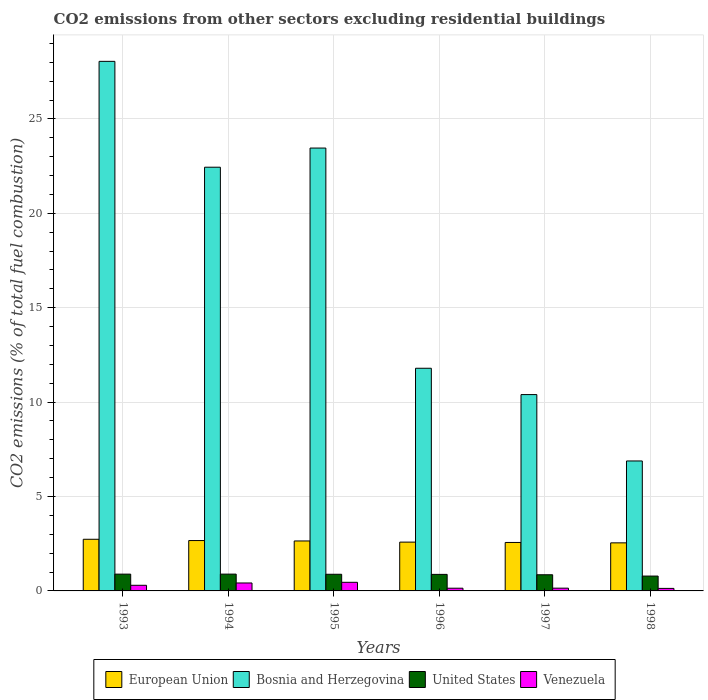How many bars are there on the 2nd tick from the right?
Make the answer very short. 4. What is the label of the 1st group of bars from the left?
Your answer should be compact. 1993. In how many cases, is the number of bars for a given year not equal to the number of legend labels?
Your answer should be very brief. 0. What is the total CO2 emitted in European Union in 1995?
Your answer should be compact. 2.65. Across all years, what is the maximum total CO2 emitted in European Union?
Your response must be concise. 2.74. Across all years, what is the minimum total CO2 emitted in Bosnia and Herzegovina?
Your answer should be very brief. 6.88. In which year was the total CO2 emitted in United States maximum?
Provide a short and direct response. 1994. In which year was the total CO2 emitted in Venezuela minimum?
Ensure brevity in your answer.  1998. What is the total total CO2 emitted in European Union in the graph?
Your answer should be compact. 15.75. What is the difference between the total CO2 emitted in Bosnia and Herzegovina in 1993 and that in 1996?
Offer a very short reply. 16.26. What is the difference between the total CO2 emitted in Bosnia and Herzegovina in 1997 and the total CO2 emitted in European Union in 1995?
Give a very brief answer. 7.75. What is the average total CO2 emitted in Venezuela per year?
Give a very brief answer. 0.27. In the year 1993, what is the difference between the total CO2 emitted in European Union and total CO2 emitted in Bosnia and Herzegovina?
Provide a succinct answer. -25.31. In how many years, is the total CO2 emitted in United States greater than 23?
Provide a short and direct response. 0. What is the ratio of the total CO2 emitted in United States in 1994 to that in 1996?
Your answer should be compact. 1.02. Is the total CO2 emitted in Venezuela in 1993 less than that in 1998?
Your answer should be compact. No. Is the difference between the total CO2 emitted in European Union in 1994 and 1996 greater than the difference between the total CO2 emitted in Bosnia and Herzegovina in 1994 and 1996?
Give a very brief answer. No. What is the difference between the highest and the second highest total CO2 emitted in Bosnia and Herzegovina?
Offer a terse response. 4.59. What is the difference between the highest and the lowest total CO2 emitted in United States?
Provide a short and direct response. 0.1. In how many years, is the total CO2 emitted in Bosnia and Herzegovina greater than the average total CO2 emitted in Bosnia and Herzegovina taken over all years?
Offer a very short reply. 3. Is the sum of the total CO2 emitted in Venezuela in 1993 and 1994 greater than the maximum total CO2 emitted in Bosnia and Herzegovina across all years?
Your response must be concise. No. What does the 3rd bar from the right in 1994 represents?
Provide a short and direct response. Bosnia and Herzegovina. How many bars are there?
Your answer should be very brief. 24. How many years are there in the graph?
Provide a short and direct response. 6. What is the difference between two consecutive major ticks on the Y-axis?
Your answer should be compact. 5. Where does the legend appear in the graph?
Offer a terse response. Bottom center. How are the legend labels stacked?
Your answer should be very brief. Horizontal. What is the title of the graph?
Offer a terse response. CO2 emissions from other sectors excluding residential buildings. Does "Greenland" appear as one of the legend labels in the graph?
Your answer should be very brief. No. What is the label or title of the X-axis?
Give a very brief answer. Years. What is the label or title of the Y-axis?
Give a very brief answer. CO2 emissions (% of total fuel combustion). What is the CO2 emissions (% of total fuel combustion) of European Union in 1993?
Offer a very short reply. 2.74. What is the CO2 emissions (% of total fuel combustion) in Bosnia and Herzegovina in 1993?
Give a very brief answer. 28.05. What is the CO2 emissions (% of total fuel combustion) of United States in 1993?
Your response must be concise. 0.89. What is the CO2 emissions (% of total fuel combustion) in Venezuela in 1993?
Keep it short and to the point. 0.3. What is the CO2 emissions (% of total fuel combustion) of European Union in 1994?
Provide a short and direct response. 2.67. What is the CO2 emissions (% of total fuel combustion) in Bosnia and Herzegovina in 1994?
Give a very brief answer. 22.44. What is the CO2 emissions (% of total fuel combustion) of United States in 1994?
Your answer should be compact. 0.89. What is the CO2 emissions (% of total fuel combustion) in Venezuela in 1994?
Offer a very short reply. 0.42. What is the CO2 emissions (% of total fuel combustion) of European Union in 1995?
Your answer should be very brief. 2.65. What is the CO2 emissions (% of total fuel combustion) of Bosnia and Herzegovina in 1995?
Your response must be concise. 23.46. What is the CO2 emissions (% of total fuel combustion) in United States in 1995?
Offer a very short reply. 0.88. What is the CO2 emissions (% of total fuel combustion) of Venezuela in 1995?
Your answer should be very brief. 0.46. What is the CO2 emissions (% of total fuel combustion) of European Union in 1996?
Offer a terse response. 2.58. What is the CO2 emissions (% of total fuel combustion) in Bosnia and Herzegovina in 1996?
Offer a terse response. 11.79. What is the CO2 emissions (% of total fuel combustion) of United States in 1996?
Your answer should be compact. 0.88. What is the CO2 emissions (% of total fuel combustion) in Venezuela in 1996?
Keep it short and to the point. 0.14. What is the CO2 emissions (% of total fuel combustion) in European Union in 1997?
Give a very brief answer. 2.57. What is the CO2 emissions (% of total fuel combustion) of Bosnia and Herzegovina in 1997?
Keep it short and to the point. 10.4. What is the CO2 emissions (% of total fuel combustion) in United States in 1997?
Give a very brief answer. 0.86. What is the CO2 emissions (% of total fuel combustion) of Venezuela in 1997?
Make the answer very short. 0.15. What is the CO2 emissions (% of total fuel combustion) in European Union in 1998?
Your response must be concise. 2.55. What is the CO2 emissions (% of total fuel combustion) in Bosnia and Herzegovina in 1998?
Provide a succinct answer. 6.88. What is the CO2 emissions (% of total fuel combustion) of United States in 1998?
Ensure brevity in your answer.  0.79. What is the CO2 emissions (% of total fuel combustion) in Venezuela in 1998?
Offer a very short reply. 0.13. Across all years, what is the maximum CO2 emissions (% of total fuel combustion) of European Union?
Your response must be concise. 2.74. Across all years, what is the maximum CO2 emissions (% of total fuel combustion) in Bosnia and Herzegovina?
Give a very brief answer. 28.05. Across all years, what is the maximum CO2 emissions (% of total fuel combustion) of United States?
Make the answer very short. 0.89. Across all years, what is the maximum CO2 emissions (% of total fuel combustion) of Venezuela?
Make the answer very short. 0.46. Across all years, what is the minimum CO2 emissions (% of total fuel combustion) of European Union?
Provide a succinct answer. 2.55. Across all years, what is the minimum CO2 emissions (% of total fuel combustion) of Bosnia and Herzegovina?
Provide a succinct answer. 6.88. Across all years, what is the minimum CO2 emissions (% of total fuel combustion) in United States?
Provide a succinct answer. 0.79. Across all years, what is the minimum CO2 emissions (% of total fuel combustion) in Venezuela?
Your answer should be compact. 0.13. What is the total CO2 emissions (% of total fuel combustion) in European Union in the graph?
Your answer should be very brief. 15.75. What is the total CO2 emissions (% of total fuel combustion) in Bosnia and Herzegovina in the graph?
Keep it short and to the point. 103.02. What is the total CO2 emissions (% of total fuel combustion) of United States in the graph?
Make the answer very short. 5.18. What is the total CO2 emissions (% of total fuel combustion) in Venezuela in the graph?
Keep it short and to the point. 1.6. What is the difference between the CO2 emissions (% of total fuel combustion) of European Union in 1993 and that in 1994?
Provide a short and direct response. 0.07. What is the difference between the CO2 emissions (% of total fuel combustion) of Bosnia and Herzegovina in 1993 and that in 1994?
Offer a very short reply. 5.61. What is the difference between the CO2 emissions (% of total fuel combustion) in United States in 1993 and that in 1994?
Make the answer very short. -0. What is the difference between the CO2 emissions (% of total fuel combustion) of Venezuela in 1993 and that in 1994?
Provide a succinct answer. -0.12. What is the difference between the CO2 emissions (% of total fuel combustion) of European Union in 1993 and that in 1995?
Ensure brevity in your answer.  0.09. What is the difference between the CO2 emissions (% of total fuel combustion) in Bosnia and Herzegovina in 1993 and that in 1995?
Provide a short and direct response. 4.59. What is the difference between the CO2 emissions (% of total fuel combustion) in United States in 1993 and that in 1995?
Provide a succinct answer. 0.01. What is the difference between the CO2 emissions (% of total fuel combustion) of Venezuela in 1993 and that in 1995?
Offer a very short reply. -0.16. What is the difference between the CO2 emissions (% of total fuel combustion) of European Union in 1993 and that in 1996?
Your answer should be very brief. 0.15. What is the difference between the CO2 emissions (% of total fuel combustion) in Bosnia and Herzegovina in 1993 and that in 1996?
Offer a very short reply. 16.26. What is the difference between the CO2 emissions (% of total fuel combustion) of United States in 1993 and that in 1996?
Provide a short and direct response. 0.01. What is the difference between the CO2 emissions (% of total fuel combustion) of Venezuela in 1993 and that in 1996?
Provide a succinct answer. 0.15. What is the difference between the CO2 emissions (% of total fuel combustion) of European Union in 1993 and that in 1997?
Ensure brevity in your answer.  0.17. What is the difference between the CO2 emissions (% of total fuel combustion) in Bosnia and Herzegovina in 1993 and that in 1997?
Give a very brief answer. 17.65. What is the difference between the CO2 emissions (% of total fuel combustion) in United States in 1993 and that in 1997?
Your answer should be very brief. 0.03. What is the difference between the CO2 emissions (% of total fuel combustion) of Venezuela in 1993 and that in 1997?
Offer a very short reply. 0.15. What is the difference between the CO2 emissions (% of total fuel combustion) of European Union in 1993 and that in 1998?
Your answer should be very brief. 0.19. What is the difference between the CO2 emissions (% of total fuel combustion) in Bosnia and Herzegovina in 1993 and that in 1998?
Keep it short and to the point. 21.17. What is the difference between the CO2 emissions (% of total fuel combustion) of United States in 1993 and that in 1998?
Make the answer very short. 0.1. What is the difference between the CO2 emissions (% of total fuel combustion) in Venezuela in 1993 and that in 1998?
Keep it short and to the point. 0.16. What is the difference between the CO2 emissions (% of total fuel combustion) of European Union in 1994 and that in 1995?
Provide a short and direct response. 0.02. What is the difference between the CO2 emissions (% of total fuel combustion) of Bosnia and Herzegovina in 1994 and that in 1995?
Your answer should be compact. -1.01. What is the difference between the CO2 emissions (% of total fuel combustion) in United States in 1994 and that in 1995?
Ensure brevity in your answer.  0.01. What is the difference between the CO2 emissions (% of total fuel combustion) in Venezuela in 1994 and that in 1995?
Your answer should be very brief. -0.04. What is the difference between the CO2 emissions (% of total fuel combustion) of European Union in 1994 and that in 1996?
Offer a terse response. 0.08. What is the difference between the CO2 emissions (% of total fuel combustion) in Bosnia and Herzegovina in 1994 and that in 1996?
Your answer should be compact. 10.65. What is the difference between the CO2 emissions (% of total fuel combustion) in United States in 1994 and that in 1996?
Make the answer very short. 0.01. What is the difference between the CO2 emissions (% of total fuel combustion) of Venezuela in 1994 and that in 1996?
Provide a succinct answer. 0.28. What is the difference between the CO2 emissions (% of total fuel combustion) in European Union in 1994 and that in 1997?
Make the answer very short. 0.1. What is the difference between the CO2 emissions (% of total fuel combustion) of Bosnia and Herzegovina in 1994 and that in 1997?
Make the answer very short. 12.04. What is the difference between the CO2 emissions (% of total fuel combustion) in United States in 1994 and that in 1997?
Ensure brevity in your answer.  0.03. What is the difference between the CO2 emissions (% of total fuel combustion) of Venezuela in 1994 and that in 1997?
Offer a terse response. 0.27. What is the difference between the CO2 emissions (% of total fuel combustion) of European Union in 1994 and that in 1998?
Provide a succinct answer. 0.12. What is the difference between the CO2 emissions (% of total fuel combustion) of Bosnia and Herzegovina in 1994 and that in 1998?
Provide a short and direct response. 15.56. What is the difference between the CO2 emissions (% of total fuel combustion) of United States in 1994 and that in 1998?
Your answer should be very brief. 0.1. What is the difference between the CO2 emissions (% of total fuel combustion) in Venezuela in 1994 and that in 1998?
Ensure brevity in your answer.  0.29. What is the difference between the CO2 emissions (% of total fuel combustion) of European Union in 1995 and that in 1996?
Provide a short and direct response. 0.06. What is the difference between the CO2 emissions (% of total fuel combustion) in Bosnia and Herzegovina in 1995 and that in 1996?
Ensure brevity in your answer.  11.66. What is the difference between the CO2 emissions (% of total fuel combustion) in United States in 1995 and that in 1996?
Make the answer very short. 0.01. What is the difference between the CO2 emissions (% of total fuel combustion) of Venezuela in 1995 and that in 1996?
Provide a short and direct response. 0.31. What is the difference between the CO2 emissions (% of total fuel combustion) of European Union in 1995 and that in 1997?
Give a very brief answer. 0.08. What is the difference between the CO2 emissions (% of total fuel combustion) in Bosnia and Herzegovina in 1995 and that in 1997?
Your answer should be compact. 13.06. What is the difference between the CO2 emissions (% of total fuel combustion) of United States in 1995 and that in 1997?
Provide a succinct answer. 0.03. What is the difference between the CO2 emissions (% of total fuel combustion) of Venezuela in 1995 and that in 1997?
Your answer should be compact. 0.31. What is the difference between the CO2 emissions (% of total fuel combustion) of European Union in 1995 and that in 1998?
Ensure brevity in your answer.  0.1. What is the difference between the CO2 emissions (% of total fuel combustion) in Bosnia and Herzegovina in 1995 and that in 1998?
Provide a short and direct response. 16.57. What is the difference between the CO2 emissions (% of total fuel combustion) of United States in 1995 and that in 1998?
Make the answer very short. 0.1. What is the difference between the CO2 emissions (% of total fuel combustion) in Venezuela in 1995 and that in 1998?
Your answer should be compact. 0.32. What is the difference between the CO2 emissions (% of total fuel combustion) of European Union in 1996 and that in 1997?
Ensure brevity in your answer.  0.02. What is the difference between the CO2 emissions (% of total fuel combustion) in Bosnia and Herzegovina in 1996 and that in 1997?
Provide a short and direct response. 1.39. What is the difference between the CO2 emissions (% of total fuel combustion) in United States in 1996 and that in 1997?
Your answer should be compact. 0.02. What is the difference between the CO2 emissions (% of total fuel combustion) in Venezuela in 1996 and that in 1997?
Provide a short and direct response. -0. What is the difference between the CO2 emissions (% of total fuel combustion) of European Union in 1996 and that in 1998?
Provide a short and direct response. 0.04. What is the difference between the CO2 emissions (% of total fuel combustion) of Bosnia and Herzegovina in 1996 and that in 1998?
Your answer should be very brief. 4.91. What is the difference between the CO2 emissions (% of total fuel combustion) in United States in 1996 and that in 1998?
Provide a short and direct response. 0.09. What is the difference between the CO2 emissions (% of total fuel combustion) in Venezuela in 1996 and that in 1998?
Provide a succinct answer. 0.01. What is the difference between the CO2 emissions (% of total fuel combustion) in European Union in 1997 and that in 1998?
Your response must be concise. 0.02. What is the difference between the CO2 emissions (% of total fuel combustion) in Bosnia and Herzegovina in 1997 and that in 1998?
Your response must be concise. 3.52. What is the difference between the CO2 emissions (% of total fuel combustion) of United States in 1997 and that in 1998?
Provide a short and direct response. 0.07. What is the difference between the CO2 emissions (% of total fuel combustion) of Venezuela in 1997 and that in 1998?
Your response must be concise. 0.01. What is the difference between the CO2 emissions (% of total fuel combustion) of European Union in 1993 and the CO2 emissions (% of total fuel combustion) of Bosnia and Herzegovina in 1994?
Make the answer very short. -19.71. What is the difference between the CO2 emissions (% of total fuel combustion) in European Union in 1993 and the CO2 emissions (% of total fuel combustion) in United States in 1994?
Your response must be concise. 1.85. What is the difference between the CO2 emissions (% of total fuel combustion) of European Union in 1993 and the CO2 emissions (% of total fuel combustion) of Venezuela in 1994?
Your response must be concise. 2.32. What is the difference between the CO2 emissions (% of total fuel combustion) in Bosnia and Herzegovina in 1993 and the CO2 emissions (% of total fuel combustion) in United States in 1994?
Keep it short and to the point. 27.16. What is the difference between the CO2 emissions (% of total fuel combustion) of Bosnia and Herzegovina in 1993 and the CO2 emissions (% of total fuel combustion) of Venezuela in 1994?
Offer a very short reply. 27.63. What is the difference between the CO2 emissions (% of total fuel combustion) of United States in 1993 and the CO2 emissions (% of total fuel combustion) of Venezuela in 1994?
Your response must be concise. 0.47. What is the difference between the CO2 emissions (% of total fuel combustion) in European Union in 1993 and the CO2 emissions (% of total fuel combustion) in Bosnia and Herzegovina in 1995?
Offer a very short reply. -20.72. What is the difference between the CO2 emissions (% of total fuel combustion) of European Union in 1993 and the CO2 emissions (% of total fuel combustion) of United States in 1995?
Keep it short and to the point. 1.85. What is the difference between the CO2 emissions (% of total fuel combustion) in European Union in 1993 and the CO2 emissions (% of total fuel combustion) in Venezuela in 1995?
Give a very brief answer. 2.28. What is the difference between the CO2 emissions (% of total fuel combustion) of Bosnia and Herzegovina in 1993 and the CO2 emissions (% of total fuel combustion) of United States in 1995?
Your answer should be very brief. 27.17. What is the difference between the CO2 emissions (% of total fuel combustion) in Bosnia and Herzegovina in 1993 and the CO2 emissions (% of total fuel combustion) in Venezuela in 1995?
Make the answer very short. 27.59. What is the difference between the CO2 emissions (% of total fuel combustion) in United States in 1993 and the CO2 emissions (% of total fuel combustion) in Venezuela in 1995?
Keep it short and to the point. 0.43. What is the difference between the CO2 emissions (% of total fuel combustion) in European Union in 1993 and the CO2 emissions (% of total fuel combustion) in Bosnia and Herzegovina in 1996?
Keep it short and to the point. -9.06. What is the difference between the CO2 emissions (% of total fuel combustion) of European Union in 1993 and the CO2 emissions (% of total fuel combustion) of United States in 1996?
Your answer should be very brief. 1.86. What is the difference between the CO2 emissions (% of total fuel combustion) in European Union in 1993 and the CO2 emissions (% of total fuel combustion) in Venezuela in 1996?
Give a very brief answer. 2.59. What is the difference between the CO2 emissions (% of total fuel combustion) of Bosnia and Herzegovina in 1993 and the CO2 emissions (% of total fuel combustion) of United States in 1996?
Offer a terse response. 27.17. What is the difference between the CO2 emissions (% of total fuel combustion) in Bosnia and Herzegovina in 1993 and the CO2 emissions (% of total fuel combustion) in Venezuela in 1996?
Ensure brevity in your answer.  27.91. What is the difference between the CO2 emissions (% of total fuel combustion) of United States in 1993 and the CO2 emissions (% of total fuel combustion) of Venezuela in 1996?
Offer a terse response. 0.75. What is the difference between the CO2 emissions (% of total fuel combustion) in European Union in 1993 and the CO2 emissions (% of total fuel combustion) in Bosnia and Herzegovina in 1997?
Offer a terse response. -7.66. What is the difference between the CO2 emissions (% of total fuel combustion) in European Union in 1993 and the CO2 emissions (% of total fuel combustion) in United States in 1997?
Offer a terse response. 1.88. What is the difference between the CO2 emissions (% of total fuel combustion) in European Union in 1993 and the CO2 emissions (% of total fuel combustion) in Venezuela in 1997?
Provide a short and direct response. 2.59. What is the difference between the CO2 emissions (% of total fuel combustion) of Bosnia and Herzegovina in 1993 and the CO2 emissions (% of total fuel combustion) of United States in 1997?
Offer a very short reply. 27.19. What is the difference between the CO2 emissions (% of total fuel combustion) of Bosnia and Herzegovina in 1993 and the CO2 emissions (% of total fuel combustion) of Venezuela in 1997?
Offer a terse response. 27.9. What is the difference between the CO2 emissions (% of total fuel combustion) of United States in 1993 and the CO2 emissions (% of total fuel combustion) of Venezuela in 1997?
Give a very brief answer. 0.74. What is the difference between the CO2 emissions (% of total fuel combustion) in European Union in 1993 and the CO2 emissions (% of total fuel combustion) in Bosnia and Herzegovina in 1998?
Your response must be concise. -4.15. What is the difference between the CO2 emissions (% of total fuel combustion) in European Union in 1993 and the CO2 emissions (% of total fuel combustion) in United States in 1998?
Provide a succinct answer. 1.95. What is the difference between the CO2 emissions (% of total fuel combustion) in European Union in 1993 and the CO2 emissions (% of total fuel combustion) in Venezuela in 1998?
Make the answer very short. 2.6. What is the difference between the CO2 emissions (% of total fuel combustion) in Bosnia and Herzegovina in 1993 and the CO2 emissions (% of total fuel combustion) in United States in 1998?
Your response must be concise. 27.26. What is the difference between the CO2 emissions (% of total fuel combustion) in Bosnia and Herzegovina in 1993 and the CO2 emissions (% of total fuel combustion) in Venezuela in 1998?
Your response must be concise. 27.92. What is the difference between the CO2 emissions (% of total fuel combustion) of United States in 1993 and the CO2 emissions (% of total fuel combustion) of Venezuela in 1998?
Ensure brevity in your answer.  0.76. What is the difference between the CO2 emissions (% of total fuel combustion) of European Union in 1994 and the CO2 emissions (% of total fuel combustion) of Bosnia and Herzegovina in 1995?
Your answer should be compact. -20.79. What is the difference between the CO2 emissions (% of total fuel combustion) in European Union in 1994 and the CO2 emissions (% of total fuel combustion) in United States in 1995?
Make the answer very short. 1.79. What is the difference between the CO2 emissions (% of total fuel combustion) in European Union in 1994 and the CO2 emissions (% of total fuel combustion) in Venezuela in 1995?
Offer a very short reply. 2.21. What is the difference between the CO2 emissions (% of total fuel combustion) of Bosnia and Herzegovina in 1994 and the CO2 emissions (% of total fuel combustion) of United States in 1995?
Keep it short and to the point. 21.56. What is the difference between the CO2 emissions (% of total fuel combustion) of Bosnia and Herzegovina in 1994 and the CO2 emissions (% of total fuel combustion) of Venezuela in 1995?
Your answer should be very brief. 21.99. What is the difference between the CO2 emissions (% of total fuel combustion) in United States in 1994 and the CO2 emissions (% of total fuel combustion) in Venezuela in 1995?
Your response must be concise. 0.43. What is the difference between the CO2 emissions (% of total fuel combustion) of European Union in 1994 and the CO2 emissions (% of total fuel combustion) of Bosnia and Herzegovina in 1996?
Give a very brief answer. -9.13. What is the difference between the CO2 emissions (% of total fuel combustion) of European Union in 1994 and the CO2 emissions (% of total fuel combustion) of United States in 1996?
Your response must be concise. 1.79. What is the difference between the CO2 emissions (% of total fuel combustion) in European Union in 1994 and the CO2 emissions (% of total fuel combustion) in Venezuela in 1996?
Keep it short and to the point. 2.52. What is the difference between the CO2 emissions (% of total fuel combustion) in Bosnia and Herzegovina in 1994 and the CO2 emissions (% of total fuel combustion) in United States in 1996?
Make the answer very short. 21.57. What is the difference between the CO2 emissions (% of total fuel combustion) of Bosnia and Herzegovina in 1994 and the CO2 emissions (% of total fuel combustion) of Venezuela in 1996?
Your response must be concise. 22.3. What is the difference between the CO2 emissions (% of total fuel combustion) in United States in 1994 and the CO2 emissions (% of total fuel combustion) in Venezuela in 1996?
Your answer should be compact. 0.75. What is the difference between the CO2 emissions (% of total fuel combustion) in European Union in 1994 and the CO2 emissions (% of total fuel combustion) in Bosnia and Herzegovina in 1997?
Give a very brief answer. -7.73. What is the difference between the CO2 emissions (% of total fuel combustion) of European Union in 1994 and the CO2 emissions (% of total fuel combustion) of United States in 1997?
Offer a terse response. 1.81. What is the difference between the CO2 emissions (% of total fuel combustion) in European Union in 1994 and the CO2 emissions (% of total fuel combustion) in Venezuela in 1997?
Your answer should be very brief. 2.52. What is the difference between the CO2 emissions (% of total fuel combustion) of Bosnia and Herzegovina in 1994 and the CO2 emissions (% of total fuel combustion) of United States in 1997?
Ensure brevity in your answer.  21.59. What is the difference between the CO2 emissions (% of total fuel combustion) in Bosnia and Herzegovina in 1994 and the CO2 emissions (% of total fuel combustion) in Venezuela in 1997?
Your answer should be very brief. 22.3. What is the difference between the CO2 emissions (% of total fuel combustion) in United States in 1994 and the CO2 emissions (% of total fuel combustion) in Venezuela in 1997?
Your answer should be very brief. 0.74. What is the difference between the CO2 emissions (% of total fuel combustion) in European Union in 1994 and the CO2 emissions (% of total fuel combustion) in Bosnia and Herzegovina in 1998?
Give a very brief answer. -4.22. What is the difference between the CO2 emissions (% of total fuel combustion) of European Union in 1994 and the CO2 emissions (% of total fuel combustion) of United States in 1998?
Your answer should be very brief. 1.88. What is the difference between the CO2 emissions (% of total fuel combustion) of European Union in 1994 and the CO2 emissions (% of total fuel combustion) of Venezuela in 1998?
Your response must be concise. 2.53. What is the difference between the CO2 emissions (% of total fuel combustion) in Bosnia and Herzegovina in 1994 and the CO2 emissions (% of total fuel combustion) in United States in 1998?
Your answer should be compact. 21.66. What is the difference between the CO2 emissions (% of total fuel combustion) in Bosnia and Herzegovina in 1994 and the CO2 emissions (% of total fuel combustion) in Venezuela in 1998?
Provide a succinct answer. 22.31. What is the difference between the CO2 emissions (% of total fuel combustion) of United States in 1994 and the CO2 emissions (% of total fuel combustion) of Venezuela in 1998?
Provide a succinct answer. 0.76. What is the difference between the CO2 emissions (% of total fuel combustion) of European Union in 1995 and the CO2 emissions (% of total fuel combustion) of Bosnia and Herzegovina in 1996?
Give a very brief answer. -9.15. What is the difference between the CO2 emissions (% of total fuel combustion) of European Union in 1995 and the CO2 emissions (% of total fuel combustion) of United States in 1996?
Provide a succinct answer. 1.77. What is the difference between the CO2 emissions (% of total fuel combustion) in European Union in 1995 and the CO2 emissions (% of total fuel combustion) in Venezuela in 1996?
Your answer should be compact. 2.5. What is the difference between the CO2 emissions (% of total fuel combustion) of Bosnia and Herzegovina in 1995 and the CO2 emissions (% of total fuel combustion) of United States in 1996?
Make the answer very short. 22.58. What is the difference between the CO2 emissions (% of total fuel combustion) in Bosnia and Herzegovina in 1995 and the CO2 emissions (% of total fuel combustion) in Venezuela in 1996?
Keep it short and to the point. 23.31. What is the difference between the CO2 emissions (% of total fuel combustion) of United States in 1995 and the CO2 emissions (% of total fuel combustion) of Venezuela in 1996?
Your answer should be compact. 0.74. What is the difference between the CO2 emissions (% of total fuel combustion) of European Union in 1995 and the CO2 emissions (% of total fuel combustion) of Bosnia and Herzegovina in 1997?
Make the answer very short. -7.75. What is the difference between the CO2 emissions (% of total fuel combustion) of European Union in 1995 and the CO2 emissions (% of total fuel combustion) of United States in 1997?
Provide a succinct answer. 1.79. What is the difference between the CO2 emissions (% of total fuel combustion) in European Union in 1995 and the CO2 emissions (% of total fuel combustion) in Venezuela in 1997?
Provide a succinct answer. 2.5. What is the difference between the CO2 emissions (% of total fuel combustion) of Bosnia and Herzegovina in 1995 and the CO2 emissions (% of total fuel combustion) of United States in 1997?
Your answer should be very brief. 22.6. What is the difference between the CO2 emissions (% of total fuel combustion) of Bosnia and Herzegovina in 1995 and the CO2 emissions (% of total fuel combustion) of Venezuela in 1997?
Your answer should be compact. 23.31. What is the difference between the CO2 emissions (% of total fuel combustion) in United States in 1995 and the CO2 emissions (% of total fuel combustion) in Venezuela in 1997?
Your answer should be very brief. 0.74. What is the difference between the CO2 emissions (% of total fuel combustion) of European Union in 1995 and the CO2 emissions (% of total fuel combustion) of Bosnia and Herzegovina in 1998?
Provide a succinct answer. -4.24. What is the difference between the CO2 emissions (% of total fuel combustion) in European Union in 1995 and the CO2 emissions (% of total fuel combustion) in United States in 1998?
Offer a very short reply. 1.86. What is the difference between the CO2 emissions (% of total fuel combustion) of European Union in 1995 and the CO2 emissions (% of total fuel combustion) of Venezuela in 1998?
Give a very brief answer. 2.51. What is the difference between the CO2 emissions (% of total fuel combustion) in Bosnia and Herzegovina in 1995 and the CO2 emissions (% of total fuel combustion) in United States in 1998?
Offer a very short reply. 22.67. What is the difference between the CO2 emissions (% of total fuel combustion) in Bosnia and Herzegovina in 1995 and the CO2 emissions (% of total fuel combustion) in Venezuela in 1998?
Offer a terse response. 23.32. What is the difference between the CO2 emissions (% of total fuel combustion) in United States in 1995 and the CO2 emissions (% of total fuel combustion) in Venezuela in 1998?
Your response must be concise. 0.75. What is the difference between the CO2 emissions (% of total fuel combustion) in European Union in 1996 and the CO2 emissions (% of total fuel combustion) in Bosnia and Herzegovina in 1997?
Your answer should be very brief. -7.81. What is the difference between the CO2 emissions (% of total fuel combustion) of European Union in 1996 and the CO2 emissions (% of total fuel combustion) of United States in 1997?
Provide a short and direct response. 1.73. What is the difference between the CO2 emissions (% of total fuel combustion) in European Union in 1996 and the CO2 emissions (% of total fuel combustion) in Venezuela in 1997?
Provide a succinct answer. 2.44. What is the difference between the CO2 emissions (% of total fuel combustion) in Bosnia and Herzegovina in 1996 and the CO2 emissions (% of total fuel combustion) in United States in 1997?
Your answer should be compact. 10.94. What is the difference between the CO2 emissions (% of total fuel combustion) of Bosnia and Herzegovina in 1996 and the CO2 emissions (% of total fuel combustion) of Venezuela in 1997?
Offer a terse response. 11.65. What is the difference between the CO2 emissions (% of total fuel combustion) of United States in 1996 and the CO2 emissions (% of total fuel combustion) of Venezuela in 1997?
Give a very brief answer. 0.73. What is the difference between the CO2 emissions (% of total fuel combustion) in European Union in 1996 and the CO2 emissions (% of total fuel combustion) in Bosnia and Herzegovina in 1998?
Your response must be concise. -4.3. What is the difference between the CO2 emissions (% of total fuel combustion) in European Union in 1996 and the CO2 emissions (% of total fuel combustion) in United States in 1998?
Your answer should be compact. 1.8. What is the difference between the CO2 emissions (% of total fuel combustion) of European Union in 1996 and the CO2 emissions (% of total fuel combustion) of Venezuela in 1998?
Ensure brevity in your answer.  2.45. What is the difference between the CO2 emissions (% of total fuel combustion) in Bosnia and Herzegovina in 1996 and the CO2 emissions (% of total fuel combustion) in United States in 1998?
Offer a terse response. 11.01. What is the difference between the CO2 emissions (% of total fuel combustion) of Bosnia and Herzegovina in 1996 and the CO2 emissions (% of total fuel combustion) of Venezuela in 1998?
Your answer should be very brief. 11.66. What is the difference between the CO2 emissions (% of total fuel combustion) of United States in 1996 and the CO2 emissions (% of total fuel combustion) of Venezuela in 1998?
Make the answer very short. 0.74. What is the difference between the CO2 emissions (% of total fuel combustion) of European Union in 1997 and the CO2 emissions (% of total fuel combustion) of Bosnia and Herzegovina in 1998?
Make the answer very short. -4.32. What is the difference between the CO2 emissions (% of total fuel combustion) of European Union in 1997 and the CO2 emissions (% of total fuel combustion) of United States in 1998?
Your response must be concise. 1.78. What is the difference between the CO2 emissions (% of total fuel combustion) of European Union in 1997 and the CO2 emissions (% of total fuel combustion) of Venezuela in 1998?
Give a very brief answer. 2.43. What is the difference between the CO2 emissions (% of total fuel combustion) of Bosnia and Herzegovina in 1997 and the CO2 emissions (% of total fuel combustion) of United States in 1998?
Your answer should be very brief. 9.61. What is the difference between the CO2 emissions (% of total fuel combustion) of Bosnia and Herzegovina in 1997 and the CO2 emissions (% of total fuel combustion) of Venezuela in 1998?
Provide a succinct answer. 10.27. What is the difference between the CO2 emissions (% of total fuel combustion) in United States in 1997 and the CO2 emissions (% of total fuel combustion) in Venezuela in 1998?
Your answer should be compact. 0.72. What is the average CO2 emissions (% of total fuel combustion) in European Union per year?
Offer a terse response. 2.62. What is the average CO2 emissions (% of total fuel combustion) of Bosnia and Herzegovina per year?
Your answer should be very brief. 17.17. What is the average CO2 emissions (% of total fuel combustion) of United States per year?
Ensure brevity in your answer.  0.86. What is the average CO2 emissions (% of total fuel combustion) of Venezuela per year?
Give a very brief answer. 0.27. In the year 1993, what is the difference between the CO2 emissions (% of total fuel combustion) of European Union and CO2 emissions (% of total fuel combustion) of Bosnia and Herzegovina?
Provide a succinct answer. -25.31. In the year 1993, what is the difference between the CO2 emissions (% of total fuel combustion) of European Union and CO2 emissions (% of total fuel combustion) of United States?
Make the answer very short. 1.85. In the year 1993, what is the difference between the CO2 emissions (% of total fuel combustion) in European Union and CO2 emissions (% of total fuel combustion) in Venezuela?
Keep it short and to the point. 2.44. In the year 1993, what is the difference between the CO2 emissions (% of total fuel combustion) of Bosnia and Herzegovina and CO2 emissions (% of total fuel combustion) of United States?
Your response must be concise. 27.16. In the year 1993, what is the difference between the CO2 emissions (% of total fuel combustion) of Bosnia and Herzegovina and CO2 emissions (% of total fuel combustion) of Venezuela?
Give a very brief answer. 27.75. In the year 1993, what is the difference between the CO2 emissions (% of total fuel combustion) in United States and CO2 emissions (% of total fuel combustion) in Venezuela?
Make the answer very short. 0.59. In the year 1994, what is the difference between the CO2 emissions (% of total fuel combustion) in European Union and CO2 emissions (% of total fuel combustion) in Bosnia and Herzegovina?
Your answer should be very brief. -19.77. In the year 1994, what is the difference between the CO2 emissions (% of total fuel combustion) in European Union and CO2 emissions (% of total fuel combustion) in United States?
Your answer should be very brief. 1.78. In the year 1994, what is the difference between the CO2 emissions (% of total fuel combustion) in European Union and CO2 emissions (% of total fuel combustion) in Venezuela?
Your response must be concise. 2.25. In the year 1994, what is the difference between the CO2 emissions (% of total fuel combustion) of Bosnia and Herzegovina and CO2 emissions (% of total fuel combustion) of United States?
Offer a terse response. 21.55. In the year 1994, what is the difference between the CO2 emissions (% of total fuel combustion) of Bosnia and Herzegovina and CO2 emissions (% of total fuel combustion) of Venezuela?
Make the answer very short. 22.02. In the year 1994, what is the difference between the CO2 emissions (% of total fuel combustion) in United States and CO2 emissions (% of total fuel combustion) in Venezuela?
Offer a terse response. 0.47. In the year 1995, what is the difference between the CO2 emissions (% of total fuel combustion) of European Union and CO2 emissions (% of total fuel combustion) of Bosnia and Herzegovina?
Offer a very short reply. -20.81. In the year 1995, what is the difference between the CO2 emissions (% of total fuel combustion) of European Union and CO2 emissions (% of total fuel combustion) of United States?
Keep it short and to the point. 1.76. In the year 1995, what is the difference between the CO2 emissions (% of total fuel combustion) of European Union and CO2 emissions (% of total fuel combustion) of Venezuela?
Provide a succinct answer. 2.19. In the year 1995, what is the difference between the CO2 emissions (% of total fuel combustion) in Bosnia and Herzegovina and CO2 emissions (% of total fuel combustion) in United States?
Provide a succinct answer. 22.57. In the year 1995, what is the difference between the CO2 emissions (% of total fuel combustion) of Bosnia and Herzegovina and CO2 emissions (% of total fuel combustion) of Venezuela?
Keep it short and to the point. 23. In the year 1995, what is the difference between the CO2 emissions (% of total fuel combustion) in United States and CO2 emissions (% of total fuel combustion) in Venezuela?
Your response must be concise. 0.43. In the year 1996, what is the difference between the CO2 emissions (% of total fuel combustion) of European Union and CO2 emissions (% of total fuel combustion) of Bosnia and Herzegovina?
Your answer should be compact. -9.21. In the year 1996, what is the difference between the CO2 emissions (% of total fuel combustion) in European Union and CO2 emissions (% of total fuel combustion) in United States?
Your answer should be very brief. 1.71. In the year 1996, what is the difference between the CO2 emissions (% of total fuel combustion) in European Union and CO2 emissions (% of total fuel combustion) in Venezuela?
Keep it short and to the point. 2.44. In the year 1996, what is the difference between the CO2 emissions (% of total fuel combustion) in Bosnia and Herzegovina and CO2 emissions (% of total fuel combustion) in United States?
Give a very brief answer. 10.92. In the year 1996, what is the difference between the CO2 emissions (% of total fuel combustion) in Bosnia and Herzegovina and CO2 emissions (% of total fuel combustion) in Venezuela?
Your response must be concise. 11.65. In the year 1996, what is the difference between the CO2 emissions (% of total fuel combustion) in United States and CO2 emissions (% of total fuel combustion) in Venezuela?
Keep it short and to the point. 0.73. In the year 1997, what is the difference between the CO2 emissions (% of total fuel combustion) in European Union and CO2 emissions (% of total fuel combustion) in Bosnia and Herzegovina?
Make the answer very short. -7.83. In the year 1997, what is the difference between the CO2 emissions (% of total fuel combustion) of European Union and CO2 emissions (% of total fuel combustion) of United States?
Provide a short and direct response. 1.71. In the year 1997, what is the difference between the CO2 emissions (% of total fuel combustion) of European Union and CO2 emissions (% of total fuel combustion) of Venezuela?
Your answer should be very brief. 2.42. In the year 1997, what is the difference between the CO2 emissions (% of total fuel combustion) in Bosnia and Herzegovina and CO2 emissions (% of total fuel combustion) in United States?
Your answer should be compact. 9.54. In the year 1997, what is the difference between the CO2 emissions (% of total fuel combustion) of Bosnia and Herzegovina and CO2 emissions (% of total fuel combustion) of Venezuela?
Your answer should be very brief. 10.25. In the year 1997, what is the difference between the CO2 emissions (% of total fuel combustion) in United States and CO2 emissions (% of total fuel combustion) in Venezuela?
Offer a terse response. 0.71. In the year 1998, what is the difference between the CO2 emissions (% of total fuel combustion) in European Union and CO2 emissions (% of total fuel combustion) in Bosnia and Herzegovina?
Your answer should be compact. -4.34. In the year 1998, what is the difference between the CO2 emissions (% of total fuel combustion) of European Union and CO2 emissions (% of total fuel combustion) of United States?
Provide a succinct answer. 1.76. In the year 1998, what is the difference between the CO2 emissions (% of total fuel combustion) of European Union and CO2 emissions (% of total fuel combustion) of Venezuela?
Offer a terse response. 2.41. In the year 1998, what is the difference between the CO2 emissions (% of total fuel combustion) of Bosnia and Herzegovina and CO2 emissions (% of total fuel combustion) of United States?
Provide a succinct answer. 6.1. In the year 1998, what is the difference between the CO2 emissions (% of total fuel combustion) of Bosnia and Herzegovina and CO2 emissions (% of total fuel combustion) of Venezuela?
Keep it short and to the point. 6.75. In the year 1998, what is the difference between the CO2 emissions (% of total fuel combustion) of United States and CO2 emissions (% of total fuel combustion) of Venezuela?
Ensure brevity in your answer.  0.65. What is the ratio of the CO2 emissions (% of total fuel combustion) of European Union in 1993 to that in 1994?
Your answer should be very brief. 1.03. What is the ratio of the CO2 emissions (% of total fuel combustion) of Bosnia and Herzegovina in 1993 to that in 1994?
Make the answer very short. 1.25. What is the ratio of the CO2 emissions (% of total fuel combustion) in Venezuela in 1993 to that in 1994?
Make the answer very short. 0.71. What is the ratio of the CO2 emissions (% of total fuel combustion) of European Union in 1993 to that in 1995?
Your response must be concise. 1.03. What is the ratio of the CO2 emissions (% of total fuel combustion) in Bosnia and Herzegovina in 1993 to that in 1995?
Your response must be concise. 1.2. What is the ratio of the CO2 emissions (% of total fuel combustion) of United States in 1993 to that in 1995?
Provide a short and direct response. 1.01. What is the ratio of the CO2 emissions (% of total fuel combustion) in Venezuela in 1993 to that in 1995?
Your answer should be very brief. 0.65. What is the ratio of the CO2 emissions (% of total fuel combustion) of European Union in 1993 to that in 1996?
Make the answer very short. 1.06. What is the ratio of the CO2 emissions (% of total fuel combustion) of Bosnia and Herzegovina in 1993 to that in 1996?
Your answer should be compact. 2.38. What is the ratio of the CO2 emissions (% of total fuel combustion) of United States in 1993 to that in 1996?
Offer a terse response. 1.02. What is the ratio of the CO2 emissions (% of total fuel combustion) in Venezuela in 1993 to that in 1996?
Keep it short and to the point. 2.07. What is the ratio of the CO2 emissions (% of total fuel combustion) in European Union in 1993 to that in 1997?
Make the answer very short. 1.07. What is the ratio of the CO2 emissions (% of total fuel combustion) in Bosnia and Herzegovina in 1993 to that in 1997?
Your response must be concise. 2.7. What is the ratio of the CO2 emissions (% of total fuel combustion) in United States in 1993 to that in 1997?
Provide a succinct answer. 1.04. What is the ratio of the CO2 emissions (% of total fuel combustion) of Venezuela in 1993 to that in 1997?
Offer a terse response. 2.04. What is the ratio of the CO2 emissions (% of total fuel combustion) in European Union in 1993 to that in 1998?
Provide a short and direct response. 1.07. What is the ratio of the CO2 emissions (% of total fuel combustion) of Bosnia and Herzegovina in 1993 to that in 1998?
Make the answer very short. 4.07. What is the ratio of the CO2 emissions (% of total fuel combustion) in United States in 1993 to that in 1998?
Your response must be concise. 1.13. What is the ratio of the CO2 emissions (% of total fuel combustion) in Venezuela in 1993 to that in 1998?
Give a very brief answer. 2.23. What is the ratio of the CO2 emissions (% of total fuel combustion) in European Union in 1994 to that in 1995?
Provide a short and direct response. 1.01. What is the ratio of the CO2 emissions (% of total fuel combustion) in Bosnia and Herzegovina in 1994 to that in 1995?
Your answer should be compact. 0.96. What is the ratio of the CO2 emissions (% of total fuel combustion) of United States in 1994 to that in 1995?
Offer a terse response. 1.01. What is the ratio of the CO2 emissions (% of total fuel combustion) of Venezuela in 1994 to that in 1995?
Ensure brevity in your answer.  0.92. What is the ratio of the CO2 emissions (% of total fuel combustion) of European Union in 1994 to that in 1996?
Make the answer very short. 1.03. What is the ratio of the CO2 emissions (% of total fuel combustion) in Bosnia and Herzegovina in 1994 to that in 1996?
Provide a succinct answer. 1.9. What is the ratio of the CO2 emissions (% of total fuel combustion) in United States in 1994 to that in 1996?
Give a very brief answer. 1.02. What is the ratio of the CO2 emissions (% of total fuel combustion) in Venezuela in 1994 to that in 1996?
Make the answer very short. 2.92. What is the ratio of the CO2 emissions (% of total fuel combustion) of European Union in 1994 to that in 1997?
Make the answer very short. 1.04. What is the ratio of the CO2 emissions (% of total fuel combustion) in Bosnia and Herzegovina in 1994 to that in 1997?
Make the answer very short. 2.16. What is the ratio of the CO2 emissions (% of total fuel combustion) of United States in 1994 to that in 1997?
Offer a very short reply. 1.04. What is the ratio of the CO2 emissions (% of total fuel combustion) in Venezuela in 1994 to that in 1997?
Ensure brevity in your answer.  2.88. What is the ratio of the CO2 emissions (% of total fuel combustion) in European Union in 1994 to that in 1998?
Provide a succinct answer. 1.05. What is the ratio of the CO2 emissions (% of total fuel combustion) of Bosnia and Herzegovina in 1994 to that in 1998?
Ensure brevity in your answer.  3.26. What is the ratio of the CO2 emissions (% of total fuel combustion) of United States in 1994 to that in 1998?
Offer a terse response. 1.13. What is the ratio of the CO2 emissions (% of total fuel combustion) in Venezuela in 1994 to that in 1998?
Provide a short and direct response. 3.15. What is the ratio of the CO2 emissions (% of total fuel combustion) of European Union in 1995 to that in 1996?
Your response must be concise. 1.02. What is the ratio of the CO2 emissions (% of total fuel combustion) of Bosnia and Herzegovina in 1995 to that in 1996?
Your response must be concise. 1.99. What is the ratio of the CO2 emissions (% of total fuel combustion) of Venezuela in 1995 to that in 1996?
Offer a very short reply. 3.17. What is the ratio of the CO2 emissions (% of total fuel combustion) of European Union in 1995 to that in 1997?
Your response must be concise. 1.03. What is the ratio of the CO2 emissions (% of total fuel combustion) of Bosnia and Herzegovina in 1995 to that in 1997?
Offer a very short reply. 2.26. What is the ratio of the CO2 emissions (% of total fuel combustion) in United States in 1995 to that in 1997?
Ensure brevity in your answer.  1.03. What is the ratio of the CO2 emissions (% of total fuel combustion) in Venezuela in 1995 to that in 1997?
Offer a terse response. 3.12. What is the ratio of the CO2 emissions (% of total fuel combustion) in European Union in 1995 to that in 1998?
Your response must be concise. 1.04. What is the ratio of the CO2 emissions (% of total fuel combustion) in Bosnia and Herzegovina in 1995 to that in 1998?
Your answer should be compact. 3.41. What is the ratio of the CO2 emissions (% of total fuel combustion) in United States in 1995 to that in 1998?
Provide a succinct answer. 1.12. What is the ratio of the CO2 emissions (% of total fuel combustion) of Venezuela in 1995 to that in 1998?
Ensure brevity in your answer.  3.42. What is the ratio of the CO2 emissions (% of total fuel combustion) of European Union in 1996 to that in 1997?
Make the answer very short. 1.01. What is the ratio of the CO2 emissions (% of total fuel combustion) in Bosnia and Herzegovina in 1996 to that in 1997?
Offer a terse response. 1.13. What is the ratio of the CO2 emissions (% of total fuel combustion) of United States in 1996 to that in 1997?
Your answer should be compact. 1.02. What is the ratio of the CO2 emissions (% of total fuel combustion) in Venezuela in 1996 to that in 1997?
Your answer should be very brief. 0.98. What is the ratio of the CO2 emissions (% of total fuel combustion) in European Union in 1996 to that in 1998?
Your answer should be very brief. 1.02. What is the ratio of the CO2 emissions (% of total fuel combustion) in Bosnia and Herzegovina in 1996 to that in 1998?
Provide a succinct answer. 1.71. What is the ratio of the CO2 emissions (% of total fuel combustion) in United States in 1996 to that in 1998?
Offer a very short reply. 1.11. What is the ratio of the CO2 emissions (% of total fuel combustion) in Venezuela in 1996 to that in 1998?
Make the answer very short. 1.08. What is the ratio of the CO2 emissions (% of total fuel combustion) of Bosnia and Herzegovina in 1997 to that in 1998?
Provide a succinct answer. 1.51. What is the ratio of the CO2 emissions (% of total fuel combustion) in United States in 1997 to that in 1998?
Provide a short and direct response. 1.09. What is the ratio of the CO2 emissions (% of total fuel combustion) in Venezuela in 1997 to that in 1998?
Give a very brief answer. 1.1. What is the difference between the highest and the second highest CO2 emissions (% of total fuel combustion) of European Union?
Your response must be concise. 0.07. What is the difference between the highest and the second highest CO2 emissions (% of total fuel combustion) of Bosnia and Herzegovina?
Offer a very short reply. 4.59. What is the difference between the highest and the second highest CO2 emissions (% of total fuel combustion) of United States?
Offer a terse response. 0. What is the difference between the highest and the second highest CO2 emissions (% of total fuel combustion) of Venezuela?
Give a very brief answer. 0.04. What is the difference between the highest and the lowest CO2 emissions (% of total fuel combustion) in European Union?
Ensure brevity in your answer.  0.19. What is the difference between the highest and the lowest CO2 emissions (% of total fuel combustion) of Bosnia and Herzegovina?
Your answer should be very brief. 21.17. What is the difference between the highest and the lowest CO2 emissions (% of total fuel combustion) of United States?
Your response must be concise. 0.1. What is the difference between the highest and the lowest CO2 emissions (% of total fuel combustion) in Venezuela?
Make the answer very short. 0.32. 